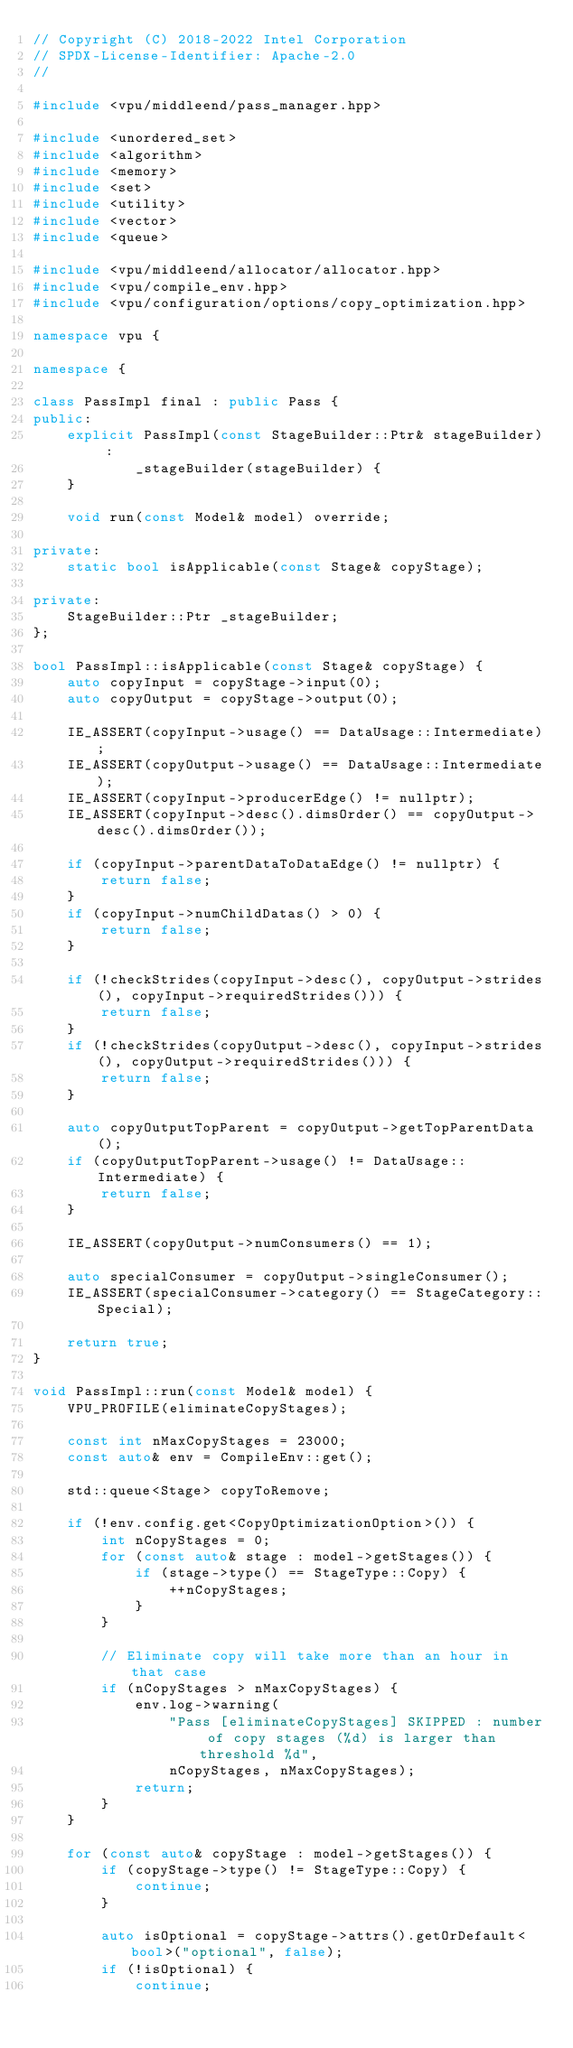Convert code to text. <code><loc_0><loc_0><loc_500><loc_500><_C++_>// Copyright (C) 2018-2022 Intel Corporation
// SPDX-License-Identifier: Apache-2.0
//

#include <vpu/middleend/pass_manager.hpp>

#include <unordered_set>
#include <algorithm>
#include <memory>
#include <set>
#include <utility>
#include <vector>
#include <queue>

#include <vpu/middleend/allocator/allocator.hpp>
#include <vpu/compile_env.hpp>
#include <vpu/configuration/options/copy_optimization.hpp>

namespace vpu {

namespace {

class PassImpl final : public Pass {
public:
    explicit PassImpl(const StageBuilder::Ptr& stageBuilder) :
            _stageBuilder(stageBuilder) {
    }

    void run(const Model& model) override;

private:
    static bool isApplicable(const Stage& copyStage);

private:
    StageBuilder::Ptr _stageBuilder;
};

bool PassImpl::isApplicable(const Stage& copyStage) {
    auto copyInput = copyStage->input(0);
    auto copyOutput = copyStage->output(0);

    IE_ASSERT(copyInput->usage() == DataUsage::Intermediate);
    IE_ASSERT(copyOutput->usage() == DataUsage::Intermediate);
    IE_ASSERT(copyInput->producerEdge() != nullptr);
    IE_ASSERT(copyInput->desc().dimsOrder() == copyOutput->desc().dimsOrder());

    if (copyInput->parentDataToDataEdge() != nullptr) {
        return false;
    }
    if (copyInput->numChildDatas() > 0) {
        return false;
    }

    if (!checkStrides(copyInput->desc(), copyOutput->strides(), copyInput->requiredStrides())) {
        return false;
    }
    if (!checkStrides(copyOutput->desc(), copyInput->strides(), copyOutput->requiredStrides())) {
        return false;
    }

    auto copyOutputTopParent = copyOutput->getTopParentData();
    if (copyOutputTopParent->usage() != DataUsage::Intermediate) {
        return false;
    }

    IE_ASSERT(copyOutput->numConsumers() == 1);

    auto specialConsumer = copyOutput->singleConsumer();
    IE_ASSERT(specialConsumer->category() == StageCategory::Special);

    return true;
}

void PassImpl::run(const Model& model) {
    VPU_PROFILE(eliminateCopyStages);

    const int nMaxCopyStages = 23000;
    const auto& env = CompileEnv::get();

    std::queue<Stage> copyToRemove;

    if (!env.config.get<CopyOptimizationOption>()) {
        int nCopyStages = 0;
        for (const auto& stage : model->getStages()) {
            if (stage->type() == StageType::Copy) {
                ++nCopyStages;
            }
        }

        // Eliminate copy will take more than an hour in that case
        if (nCopyStages > nMaxCopyStages) {
            env.log->warning(
                "Pass [eliminateCopyStages] SKIPPED : number of copy stages (%d) is larger than threshold %d",
                nCopyStages, nMaxCopyStages);
            return;
        }
    }

    for (const auto& copyStage : model->getStages()) {
        if (copyStage->type() != StageType::Copy) {
            continue;
        }

        auto isOptional = copyStage->attrs().getOrDefault<bool>("optional", false);
        if (!isOptional) {
            continue;</code> 